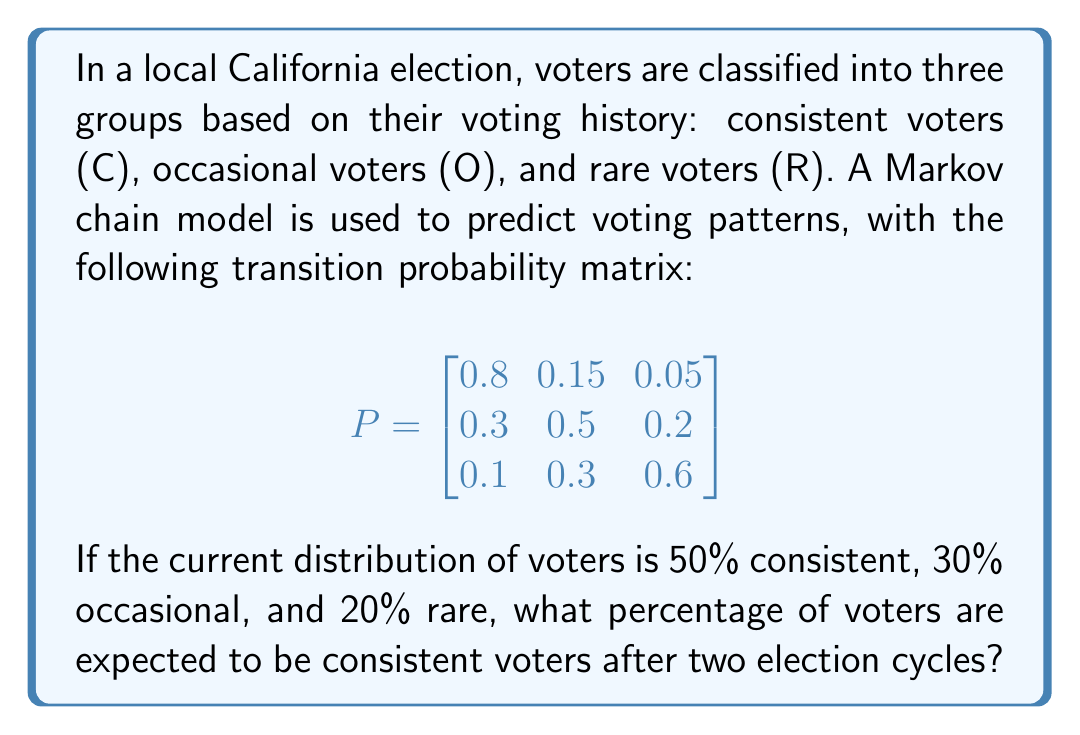Help me with this question. Let's approach this step-by-step:

1) First, we need to represent the current distribution as a row vector:
   $$\pi_0 = [0.5, 0.3, 0.2]$$

2) To find the distribution after two election cycles, we need to multiply this vector by the transition matrix twice:
   $$\pi_2 = \pi_0 \cdot P^2$$

3) Let's calculate $P^2$ first:
   $$P^2 = P \cdot P = \begin{bmatrix}
   0.8 & 0.15 & 0.05 \\
   0.3 & 0.5 & 0.2 \\
   0.1 & 0.3 & 0.6
   \end{bmatrix} \cdot \begin{bmatrix}
   0.8 & 0.15 & 0.05 \\
   0.3 & 0.5 & 0.2 \\
   0.1 & 0.3 & 0.6
   \end{bmatrix}$$

4) Multiplying these matrices:
   $$P^2 = \begin{bmatrix}
   0.67 & 0.225 & 0.105 \\
   0.39 & 0.375 & 0.235 \\
   0.22 & 0.36 & 0.42
   \end{bmatrix}$$

5) Now, we multiply $\pi_0$ by $P^2$:
   $$\pi_2 = [0.5, 0.3, 0.2] \cdot \begin{bmatrix}
   0.67 & 0.225 & 0.105 \\
   0.39 & 0.375 & 0.235 \\
   0.22 & 0.36 & 0.42
   \end{bmatrix}$$

6) Performing this multiplication:
   $$\pi_2 = [0.5(0.67) + 0.3(0.39) + 0.2(0.22), \quad ..., \quad ...]$$
   $$\pi_2 = [0.335 + 0.117 + 0.044, \quad ..., \quad ...]$$
   $$\pi_2 = [0.496, \quad 0.294, \quad 0.21]$$

7) The first element of $\pi_2$ represents the proportion of consistent voters after two election cycles.

8) Converting to a percentage: $0.496 \times 100\% = 49.6\%$
Answer: 49.6% 